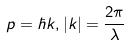Convert formula to latex. <formula><loc_0><loc_0><loc_500><loc_500>p = \hbar { k } , | k | = \frac { 2 \pi } { \lambda }</formula> 